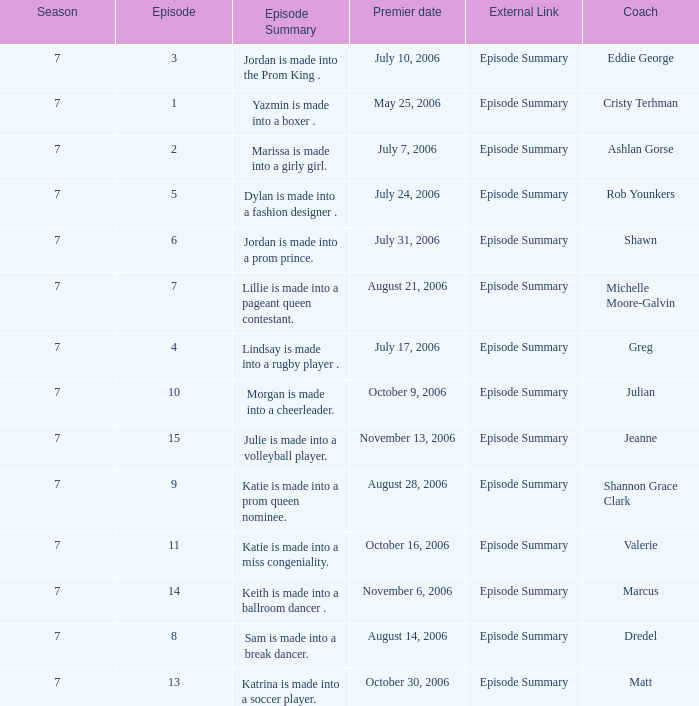How many episodes have Valerie? 1.0. 